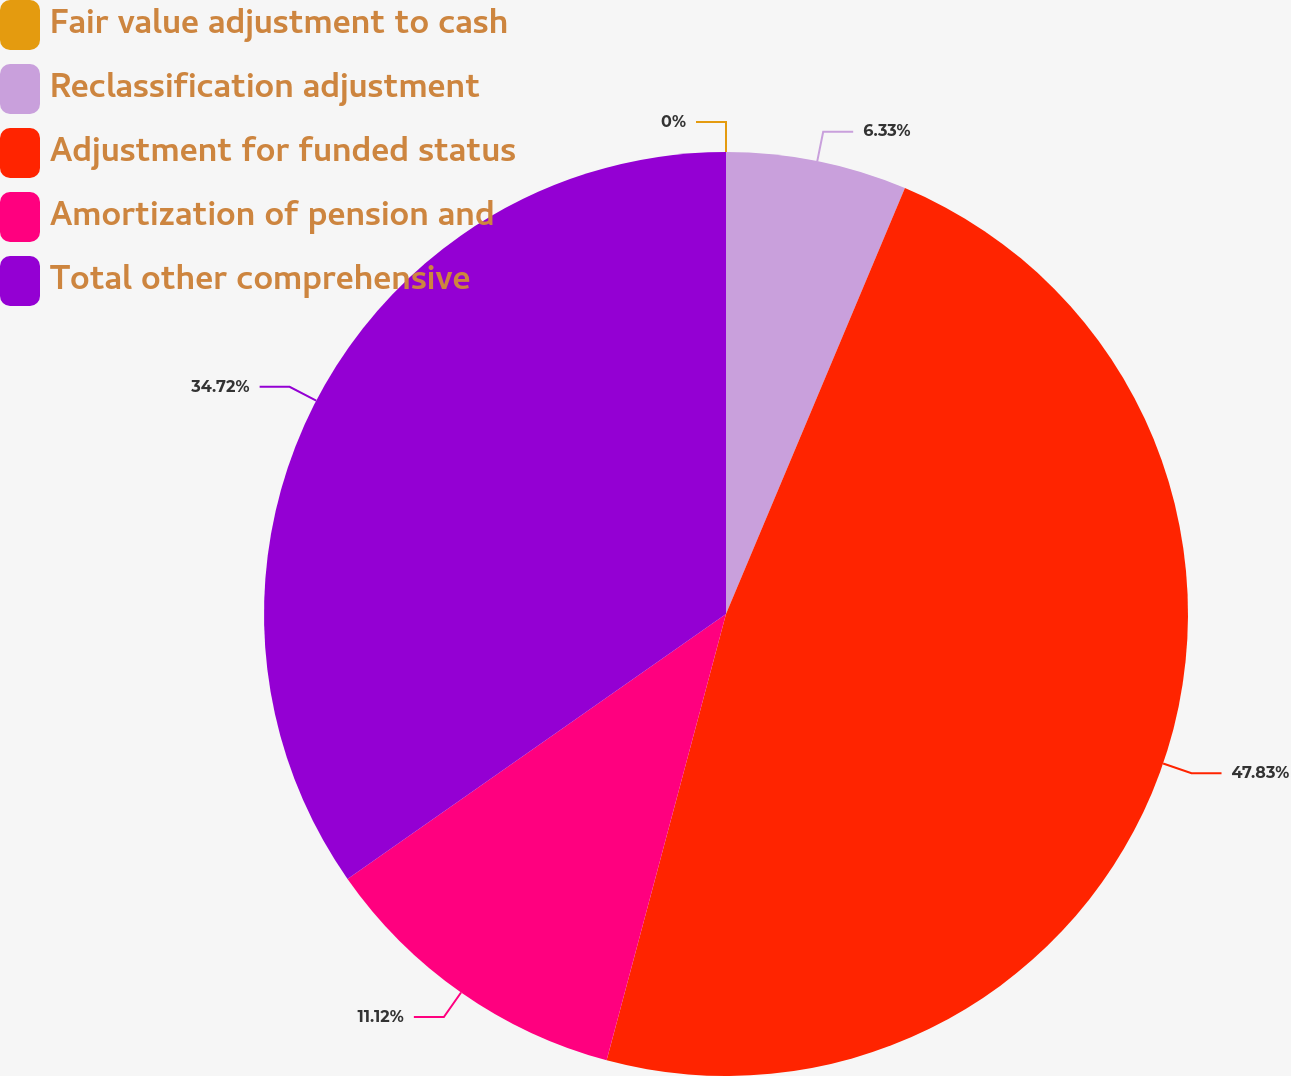Convert chart. <chart><loc_0><loc_0><loc_500><loc_500><pie_chart><fcel>Fair value adjustment to cash<fcel>Reclassification adjustment<fcel>Adjustment for funded status<fcel>Amortization of pension and<fcel>Total other comprehensive<nl><fcel>0.0%<fcel>6.33%<fcel>47.83%<fcel>11.12%<fcel>34.72%<nl></chart> 